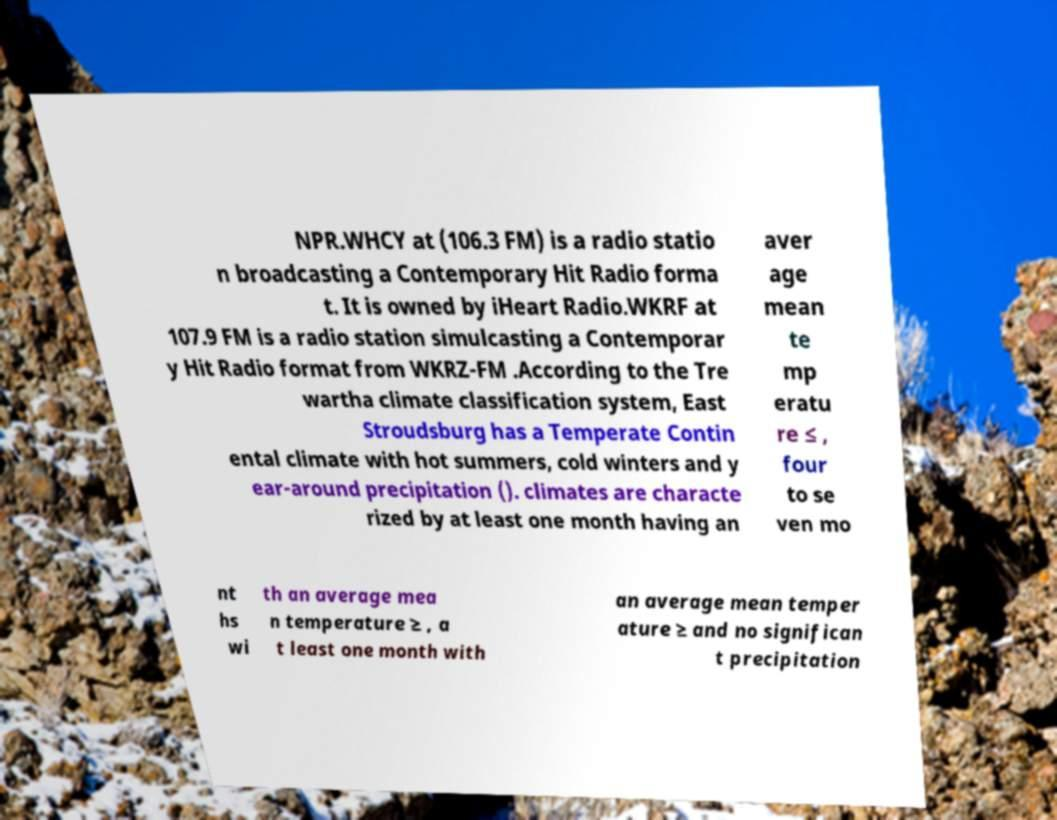There's text embedded in this image that I need extracted. Can you transcribe it verbatim? NPR.WHCY at (106.3 FM) is a radio statio n broadcasting a Contemporary Hit Radio forma t. It is owned by iHeart Radio.WKRF at 107.9 FM is a radio station simulcasting a Contemporar y Hit Radio format from WKRZ-FM .According to the Tre wartha climate classification system, East Stroudsburg has a Temperate Contin ental climate with hot summers, cold winters and y ear-around precipitation (). climates are characte rized by at least one month having an aver age mean te mp eratu re ≤ , four to se ven mo nt hs wi th an average mea n temperature ≥ , a t least one month with an average mean temper ature ≥ and no significan t precipitation 